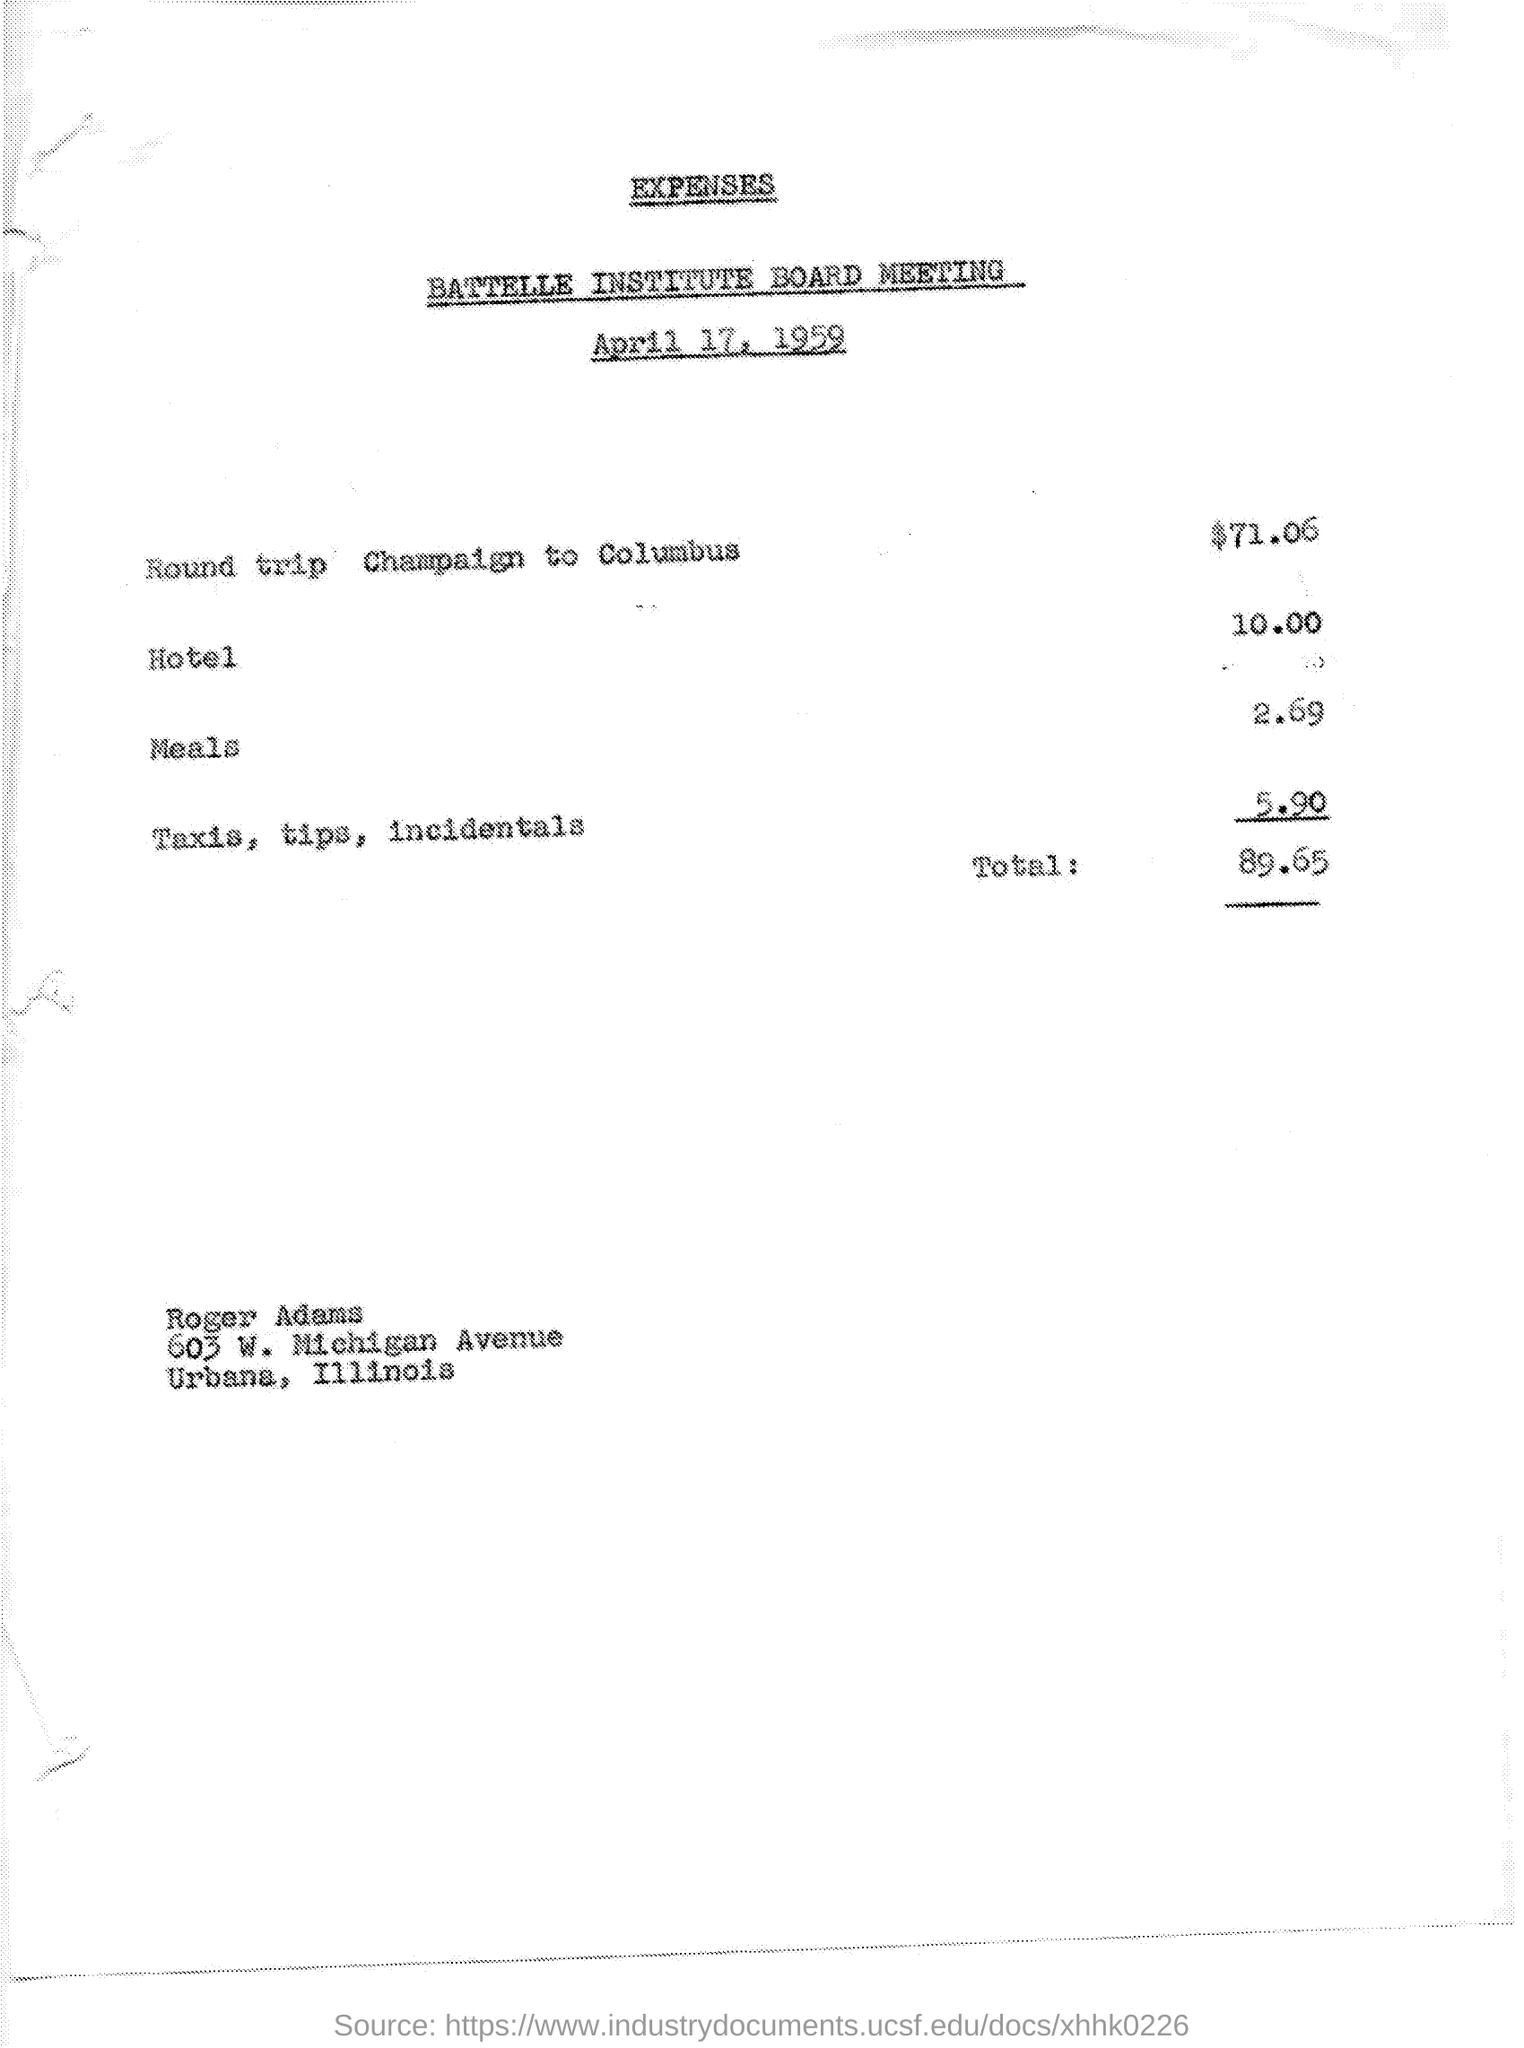Point out several critical features in this image. The date on the document is April 17, 1959. The total cost for a round trip flight from Champaign to Columbus is $71.06. The total is 89.65, rounded to the nearest cent. The cost for a hotel is 10.00. The cost for meals is 2.69. 